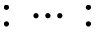<formula> <loc_0><loc_0><loc_500><loc_500>\colon \cdots \colon</formula> 